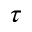Convert formula to latex. <formula><loc_0><loc_0><loc_500><loc_500>\tau</formula> 